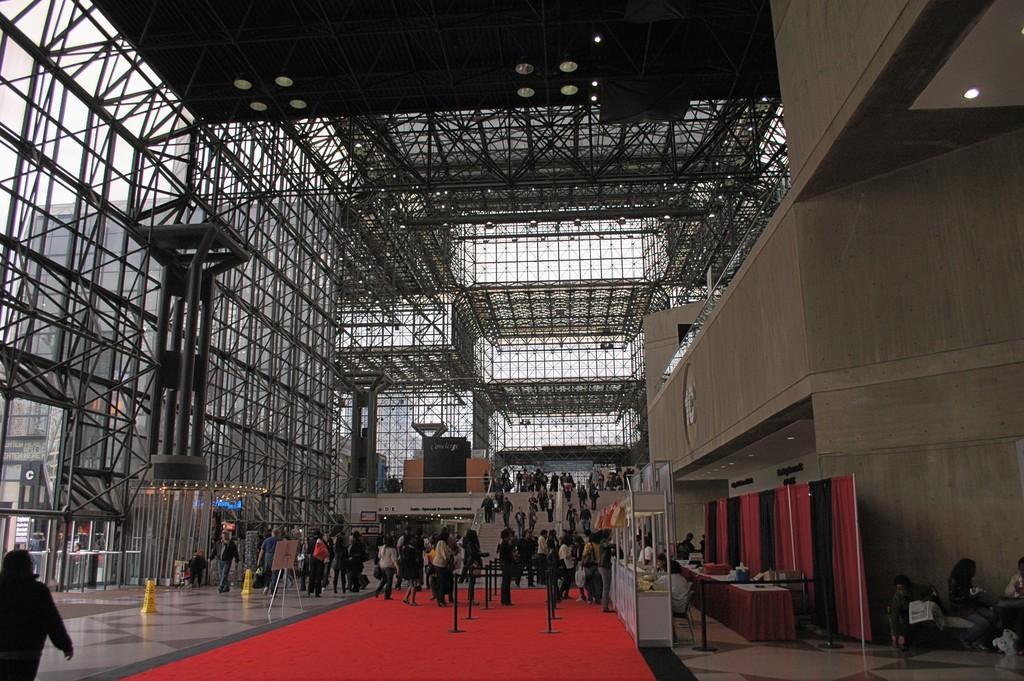Describe this image in one or two sentences. This image is taken inside the building. In this image there are people and we can see stairs. There are tables and we can see curtains. There is a countertop. At the bottom we can see a carpet. At the top there are lights and we can see rods. We can see building through the glass doors and there is a wall. There are caution boards. 